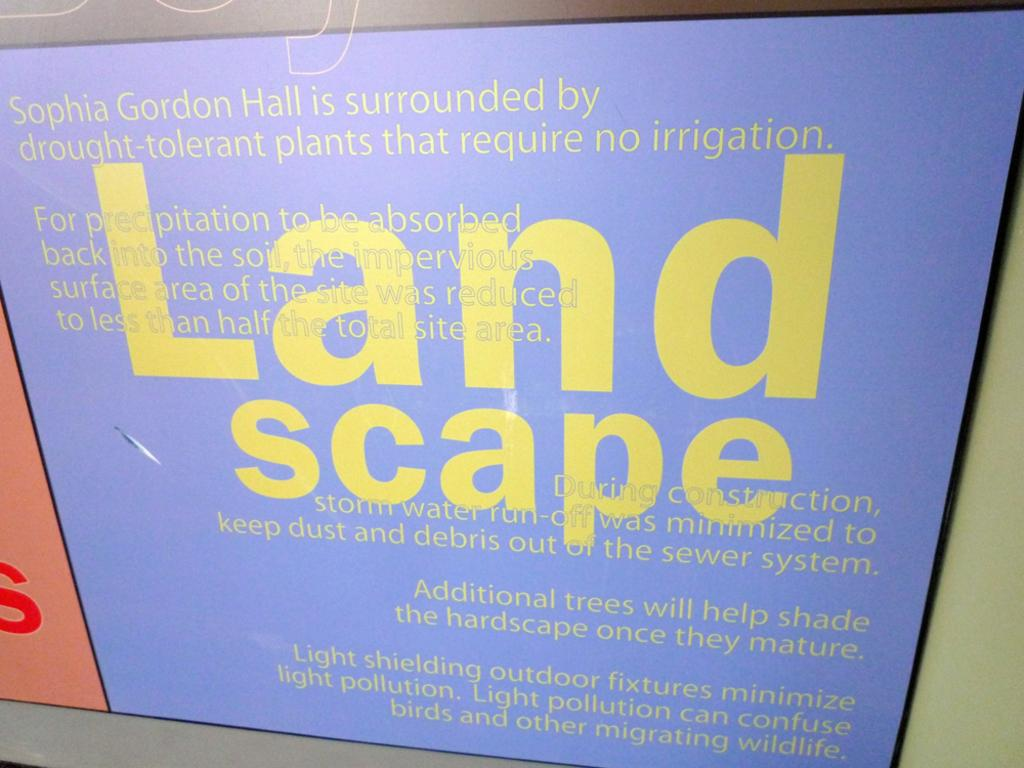<image>
Summarize the visual content of the image. A sign explaining the landscaping of Sophia Gordon Hall. 